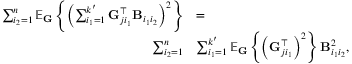Convert formula to latex. <formula><loc_0><loc_0><loc_500><loc_500>\begin{array} { r l } { \sum _ { i _ { 2 } = 1 } ^ { n } \mathbb { E } _ { G } \left \{ \left ( \sum _ { i _ { 1 } = 1 } ^ { k ^ { \prime } } G _ { j i _ { 1 } } ^ { \top } B _ { i _ { 1 } i _ { 2 } } \right ) ^ { 2 } \right \} } & { = } \\ { \sum _ { i _ { 2 } = 1 } ^ { n } } & { \sum _ { i _ { 1 } = 1 } ^ { k ^ { \prime } } \mathbb { E } _ { G } \left \{ \left ( G _ { j i _ { 1 } } ^ { \top } \right ) ^ { 2 } \right \} B _ { i _ { 1 } i _ { 2 } } ^ { 2 } , } \end{array}</formula> 